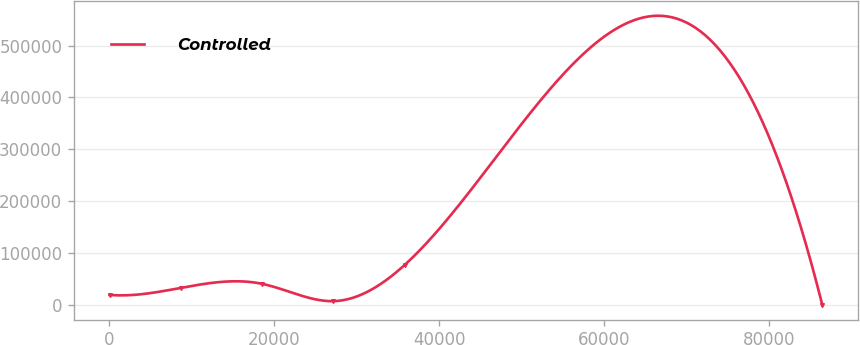Convert chart to OTSL. <chart><loc_0><loc_0><loc_500><loc_500><line_chart><ecel><fcel>Controlled<nl><fcel>28.92<fcel>19803.4<nl><fcel>8669.59<fcel>33315.2<nl><fcel>18532.1<fcel>41079.4<nl><fcel>27172.8<fcel>7791.44<nl><fcel>35813.4<fcel>77669.2<nl><fcel>86435.6<fcel>27.25<nl></chart> 